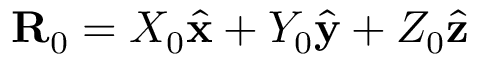Convert formula to latex. <formula><loc_0><loc_0><loc_500><loc_500>R _ { 0 } = X _ { 0 } \hat { x } + Y _ { 0 } \hat { y } + Z _ { 0 } \hat { z }</formula> 